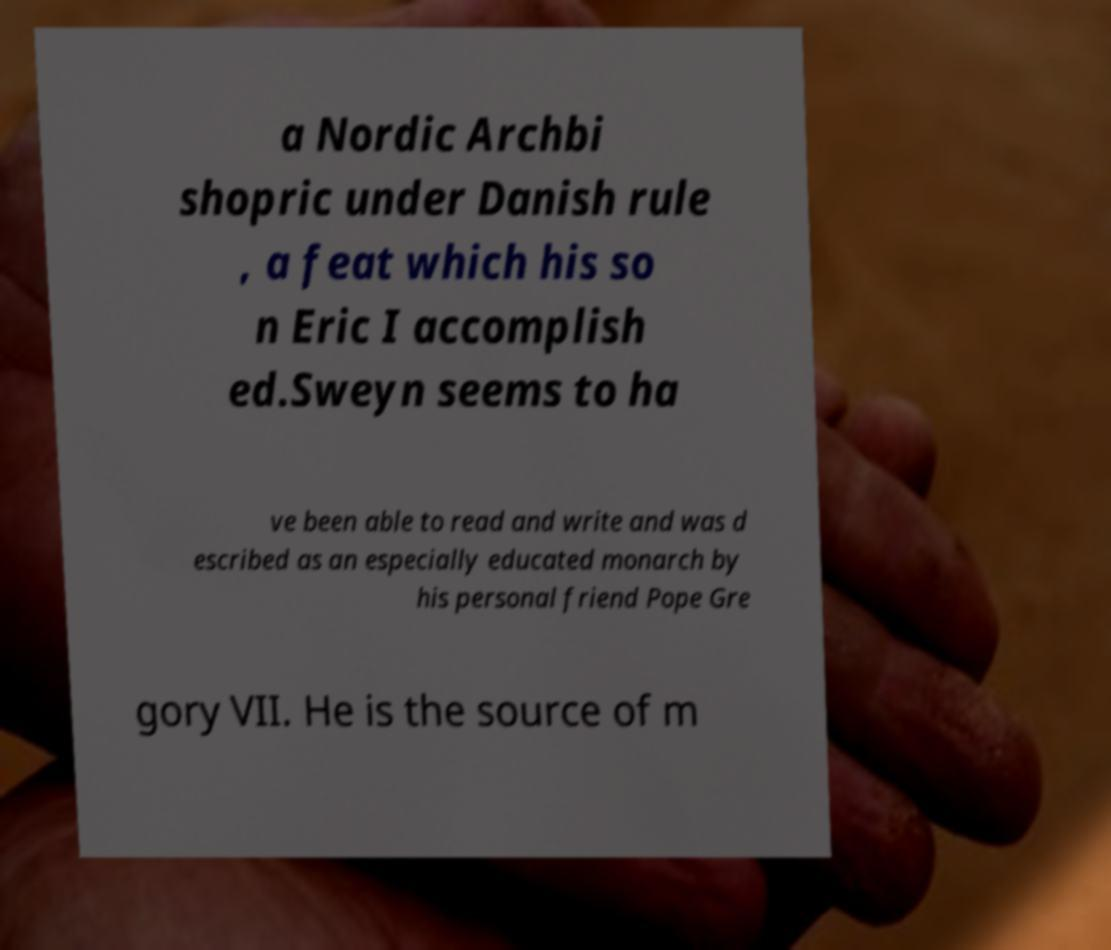Could you extract and type out the text from this image? a Nordic Archbi shopric under Danish rule , a feat which his so n Eric I accomplish ed.Sweyn seems to ha ve been able to read and write and was d escribed as an especially educated monarch by his personal friend Pope Gre gory VII. He is the source of m 